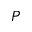Convert formula to latex. <formula><loc_0><loc_0><loc_500><loc_500>P</formula> 